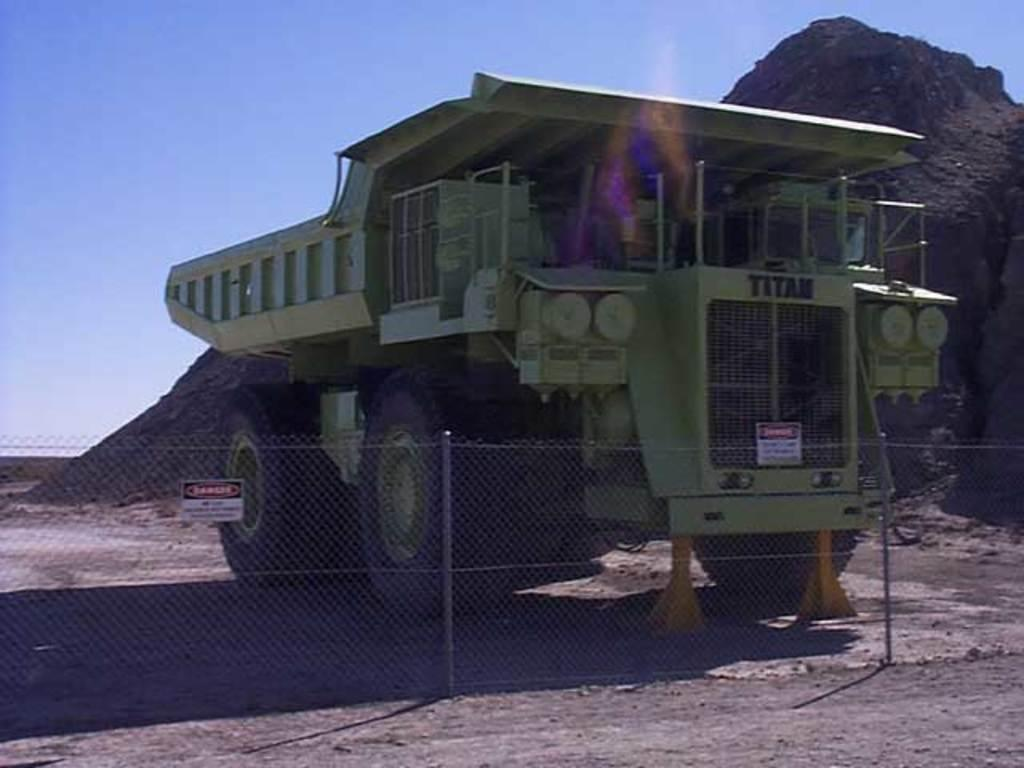What is the main subject of the image? There is a vehicle in the image. What is in front of the vehicle? There is a fencing in front of the vehicle. What can be seen behind the vehicle? There is a hill visible behind the vehicle. What is visible at the top of the image? The sky is visible at the top of the image. Where are the scissors located in the image? There are no scissors present in the image. What type of destruction can be seen happening at the seashore in the image? There is no seashore or destruction present in the image; it features a vehicle with a fencing in front and a hill behind. 